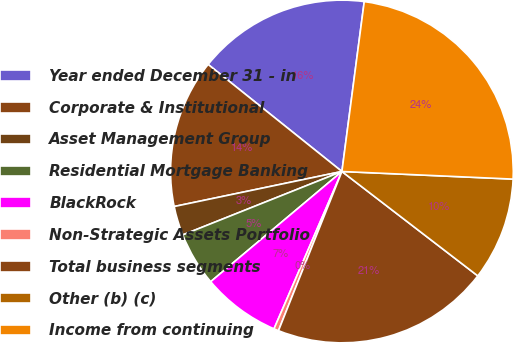Convert chart to OTSL. <chart><loc_0><loc_0><loc_500><loc_500><pie_chart><fcel>Year ended December 31 - in<fcel>Corporate & Institutional<fcel>Asset Management Group<fcel>Residential Mortgage Banking<fcel>BlackRock<fcel>Non-Strategic Assets Portfolio<fcel>Total business segments<fcel>Other (b) (c)<fcel>Income from continuing<nl><fcel>16.34%<fcel>14.02%<fcel>2.76%<fcel>5.08%<fcel>7.4%<fcel>0.45%<fcel>20.61%<fcel>9.72%<fcel>23.63%<nl></chart> 